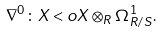Convert formula to latex. <formula><loc_0><loc_0><loc_500><loc_500>\nabla ^ { 0 } \colon X < o X \otimes _ { R } \Omega ^ { 1 } _ { R / S } .</formula> 